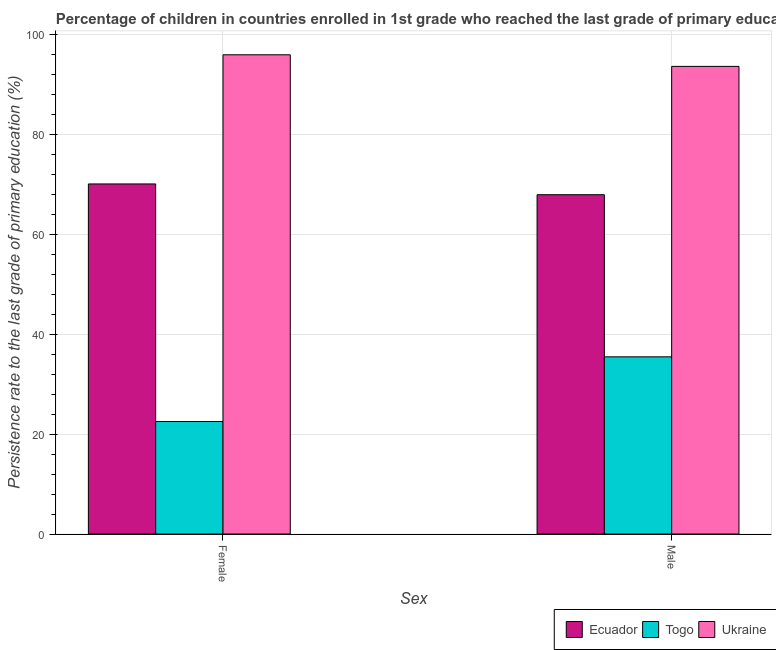How many bars are there on the 1st tick from the right?
Offer a very short reply. 3. What is the persistence rate of male students in Togo?
Ensure brevity in your answer.  35.47. Across all countries, what is the maximum persistence rate of female students?
Your answer should be compact. 95.95. Across all countries, what is the minimum persistence rate of female students?
Ensure brevity in your answer.  22.52. In which country was the persistence rate of female students maximum?
Your answer should be compact. Ukraine. In which country was the persistence rate of female students minimum?
Offer a terse response. Togo. What is the total persistence rate of male students in the graph?
Offer a very short reply. 197.02. What is the difference between the persistence rate of female students in Togo and that in Ecuador?
Provide a short and direct response. -47.56. What is the difference between the persistence rate of male students in Ecuador and the persistence rate of female students in Ukraine?
Make the answer very short. -28.01. What is the average persistence rate of male students per country?
Keep it short and to the point. 65.67. What is the difference between the persistence rate of male students and persistence rate of female students in Togo?
Keep it short and to the point. 12.95. In how many countries, is the persistence rate of male students greater than 92 %?
Provide a succinct answer. 1. What is the ratio of the persistence rate of male students in Togo to that in Ukraine?
Your answer should be compact. 0.38. What does the 3rd bar from the left in Male represents?
Make the answer very short. Ukraine. What does the 2nd bar from the right in Male represents?
Offer a terse response. Togo. Are the values on the major ticks of Y-axis written in scientific E-notation?
Give a very brief answer. No. Does the graph contain grids?
Keep it short and to the point. Yes. How are the legend labels stacked?
Offer a very short reply. Horizontal. What is the title of the graph?
Offer a terse response. Percentage of children in countries enrolled in 1st grade who reached the last grade of primary education. Does "Nicaragua" appear as one of the legend labels in the graph?
Your answer should be compact. No. What is the label or title of the X-axis?
Keep it short and to the point. Sex. What is the label or title of the Y-axis?
Offer a very short reply. Persistence rate to the last grade of primary education (%). What is the Persistence rate to the last grade of primary education (%) of Ecuador in Female?
Provide a succinct answer. 70.09. What is the Persistence rate to the last grade of primary education (%) of Togo in Female?
Your answer should be compact. 22.52. What is the Persistence rate to the last grade of primary education (%) in Ukraine in Female?
Make the answer very short. 95.95. What is the Persistence rate to the last grade of primary education (%) of Ecuador in Male?
Make the answer very short. 67.93. What is the Persistence rate to the last grade of primary education (%) of Togo in Male?
Offer a terse response. 35.47. What is the Persistence rate to the last grade of primary education (%) of Ukraine in Male?
Your answer should be compact. 93.62. Across all Sex, what is the maximum Persistence rate to the last grade of primary education (%) in Ecuador?
Offer a terse response. 70.09. Across all Sex, what is the maximum Persistence rate to the last grade of primary education (%) of Togo?
Offer a very short reply. 35.47. Across all Sex, what is the maximum Persistence rate to the last grade of primary education (%) of Ukraine?
Offer a terse response. 95.95. Across all Sex, what is the minimum Persistence rate to the last grade of primary education (%) in Ecuador?
Keep it short and to the point. 67.93. Across all Sex, what is the minimum Persistence rate to the last grade of primary education (%) of Togo?
Ensure brevity in your answer.  22.52. Across all Sex, what is the minimum Persistence rate to the last grade of primary education (%) of Ukraine?
Ensure brevity in your answer.  93.62. What is the total Persistence rate to the last grade of primary education (%) of Ecuador in the graph?
Give a very brief answer. 138.02. What is the total Persistence rate to the last grade of primary education (%) of Togo in the graph?
Keep it short and to the point. 58. What is the total Persistence rate to the last grade of primary education (%) of Ukraine in the graph?
Make the answer very short. 189.57. What is the difference between the Persistence rate to the last grade of primary education (%) in Ecuador in Female and that in Male?
Make the answer very short. 2.16. What is the difference between the Persistence rate to the last grade of primary education (%) in Togo in Female and that in Male?
Give a very brief answer. -12.95. What is the difference between the Persistence rate to the last grade of primary education (%) of Ukraine in Female and that in Male?
Your answer should be very brief. 2.32. What is the difference between the Persistence rate to the last grade of primary education (%) in Ecuador in Female and the Persistence rate to the last grade of primary education (%) in Togo in Male?
Make the answer very short. 34.62. What is the difference between the Persistence rate to the last grade of primary education (%) of Ecuador in Female and the Persistence rate to the last grade of primary education (%) of Ukraine in Male?
Ensure brevity in your answer.  -23.53. What is the difference between the Persistence rate to the last grade of primary education (%) of Togo in Female and the Persistence rate to the last grade of primary education (%) of Ukraine in Male?
Make the answer very short. -71.1. What is the average Persistence rate to the last grade of primary education (%) in Ecuador per Sex?
Give a very brief answer. 69.01. What is the average Persistence rate to the last grade of primary education (%) in Togo per Sex?
Your answer should be compact. 29. What is the average Persistence rate to the last grade of primary education (%) of Ukraine per Sex?
Provide a succinct answer. 94.78. What is the difference between the Persistence rate to the last grade of primary education (%) in Ecuador and Persistence rate to the last grade of primary education (%) in Togo in Female?
Your answer should be compact. 47.56. What is the difference between the Persistence rate to the last grade of primary education (%) in Ecuador and Persistence rate to the last grade of primary education (%) in Ukraine in Female?
Provide a short and direct response. -25.86. What is the difference between the Persistence rate to the last grade of primary education (%) in Togo and Persistence rate to the last grade of primary education (%) in Ukraine in Female?
Your answer should be very brief. -73.42. What is the difference between the Persistence rate to the last grade of primary education (%) of Ecuador and Persistence rate to the last grade of primary education (%) of Togo in Male?
Your answer should be very brief. 32.46. What is the difference between the Persistence rate to the last grade of primary education (%) in Ecuador and Persistence rate to the last grade of primary education (%) in Ukraine in Male?
Your answer should be compact. -25.69. What is the difference between the Persistence rate to the last grade of primary education (%) of Togo and Persistence rate to the last grade of primary education (%) of Ukraine in Male?
Provide a succinct answer. -58.15. What is the ratio of the Persistence rate to the last grade of primary education (%) in Ecuador in Female to that in Male?
Provide a short and direct response. 1.03. What is the ratio of the Persistence rate to the last grade of primary education (%) of Togo in Female to that in Male?
Your answer should be very brief. 0.64. What is the ratio of the Persistence rate to the last grade of primary education (%) in Ukraine in Female to that in Male?
Offer a terse response. 1.02. What is the difference between the highest and the second highest Persistence rate to the last grade of primary education (%) of Ecuador?
Keep it short and to the point. 2.16. What is the difference between the highest and the second highest Persistence rate to the last grade of primary education (%) of Togo?
Keep it short and to the point. 12.95. What is the difference between the highest and the second highest Persistence rate to the last grade of primary education (%) in Ukraine?
Provide a short and direct response. 2.32. What is the difference between the highest and the lowest Persistence rate to the last grade of primary education (%) in Ecuador?
Provide a short and direct response. 2.16. What is the difference between the highest and the lowest Persistence rate to the last grade of primary education (%) in Togo?
Your response must be concise. 12.95. What is the difference between the highest and the lowest Persistence rate to the last grade of primary education (%) of Ukraine?
Ensure brevity in your answer.  2.32. 